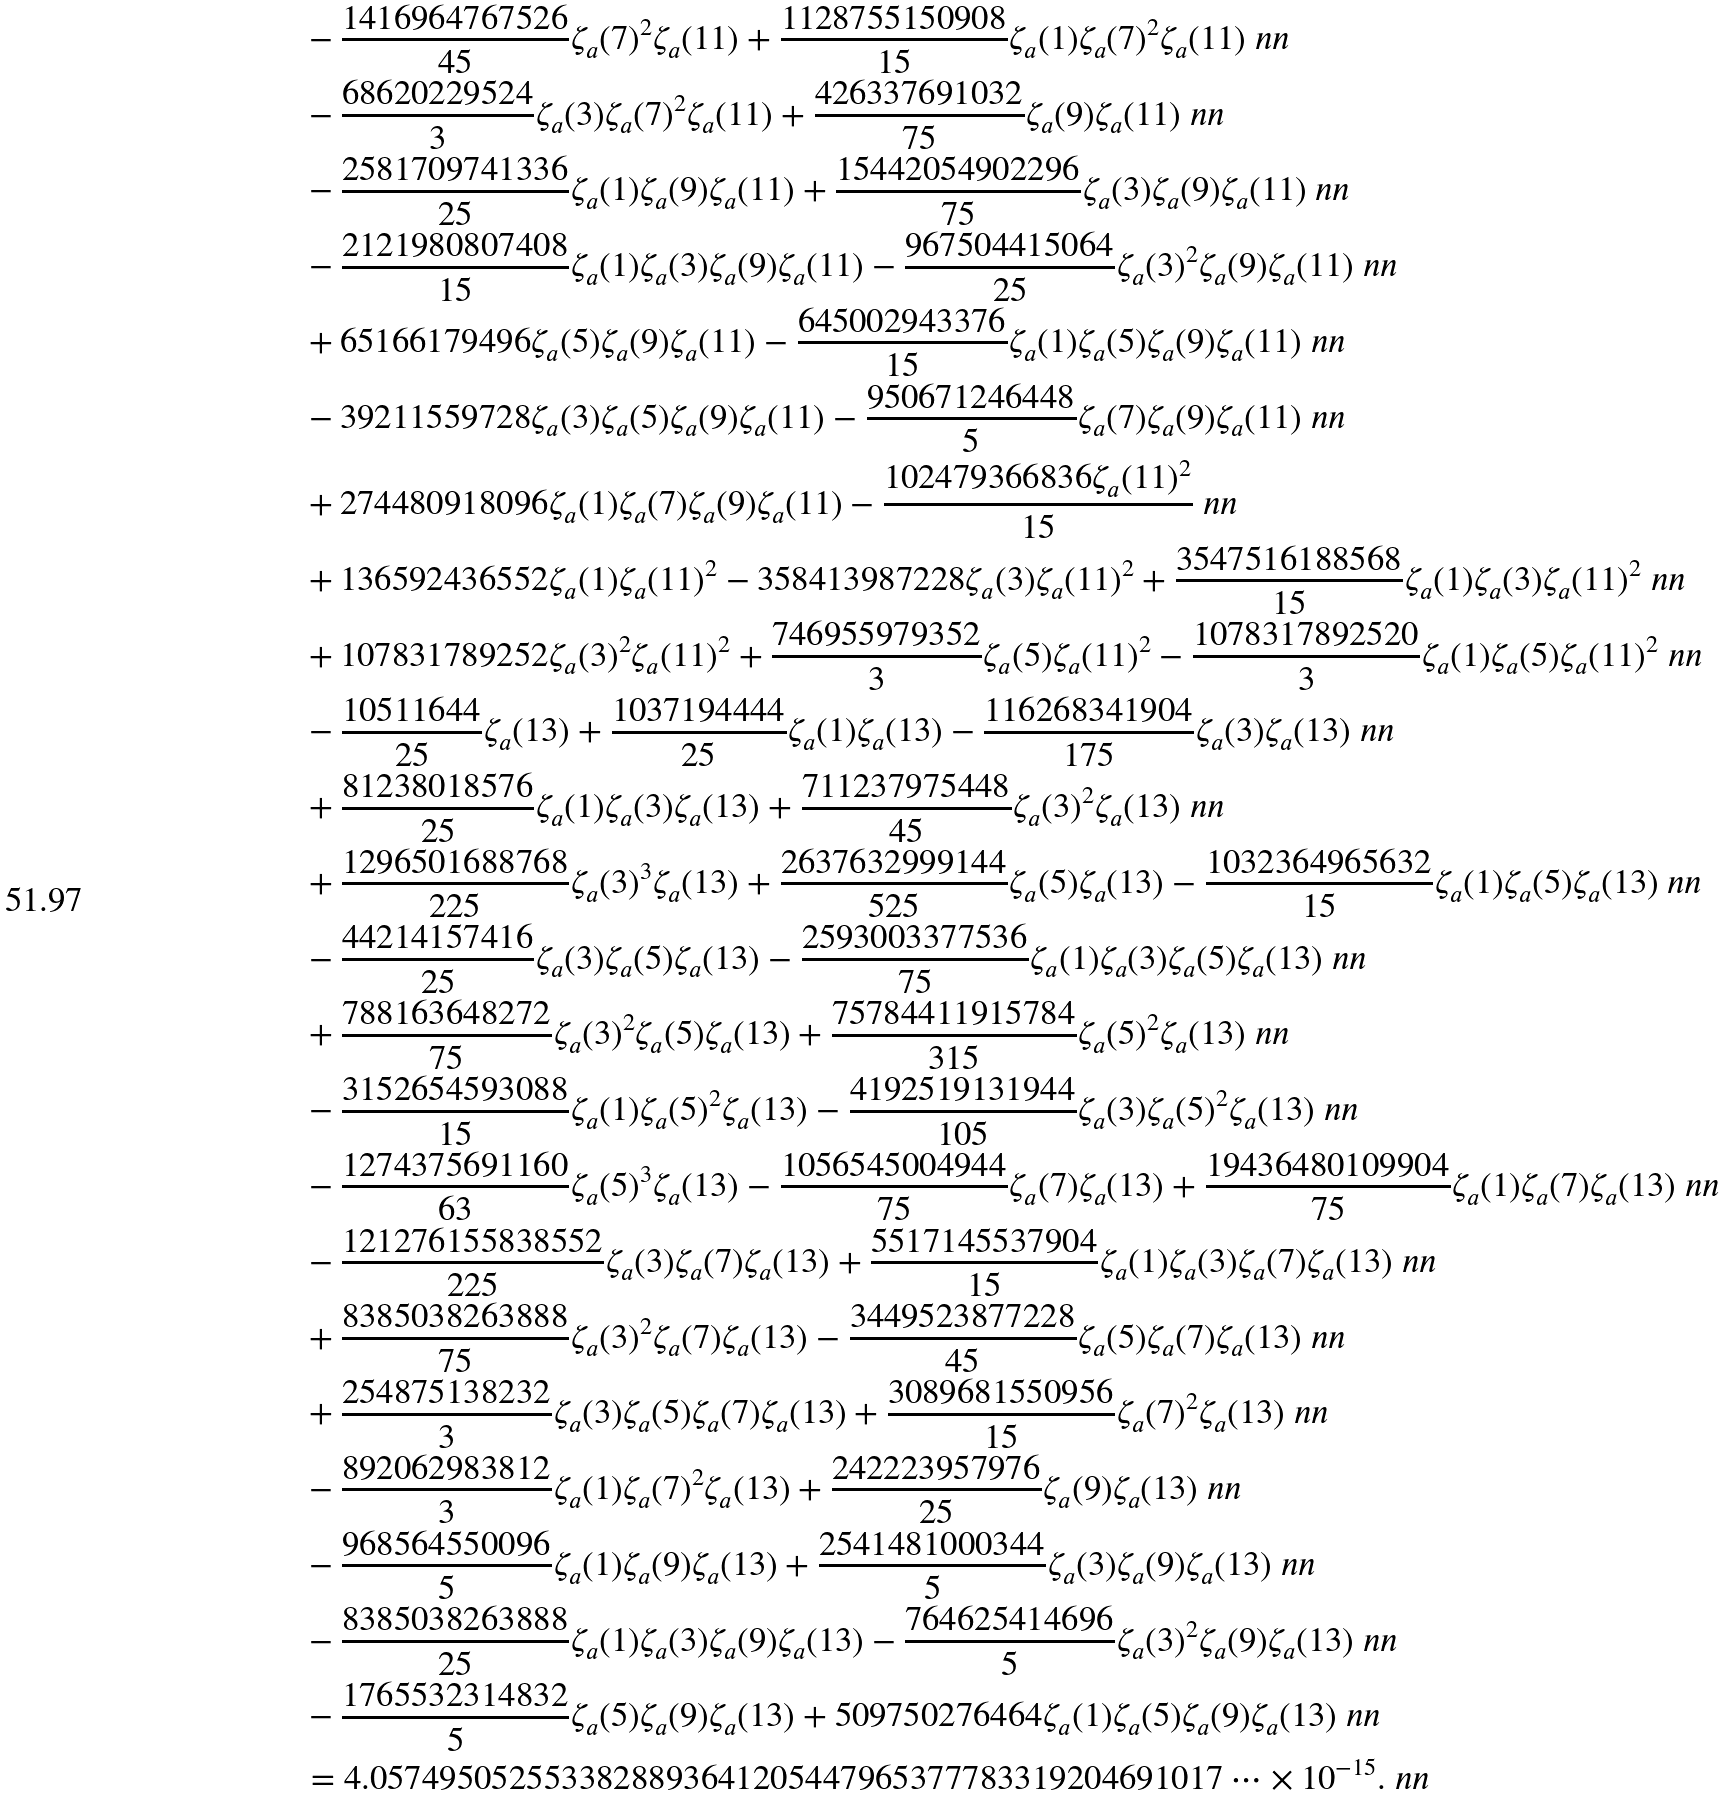<formula> <loc_0><loc_0><loc_500><loc_500>& - \frac { 1 4 1 6 9 6 4 7 6 7 5 2 6 } { 4 5 } \zeta _ { a } ( 7 ) ^ { 2 } \zeta _ { a } ( 1 1 ) + \frac { 1 1 2 8 7 5 5 1 5 0 9 0 8 } { 1 5 } \zeta _ { a } ( 1 ) \zeta _ { a } ( 7 ) ^ { 2 } \zeta _ { a } ( 1 1 ) \ n n \\ & - \frac { 6 8 6 2 0 2 2 9 5 2 4 } { 3 } \zeta _ { a } ( 3 ) \zeta _ { a } ( 7 ) ^ { 2 } \zeta _ { a } ( 1 1 ) + \frac { 4 2 6 3 3 7 6 9 1 0 3 2 } { 7 5 } \zeta _ { a } ( 9 ) \zeta _ { a } ( 1 1 ) \ n n \\ & - \frac { 2 5 8 1 7 0 9 7 4 1 3 3 6 } { 2 5 } \zeta _ { a } ( 1 ) \zeta _ { a } ( 9 ) \zeta _ { a } ( 1 1 ) + \frac { 1 5 4 4 2 0 5 4 9 0 2 2 9 6 } { 7 5 } \zeta _ { a } ( 3 ) \zeta _ { a } ( 9 ) \zeta _ { a } ( 1 1 ) \ n n \\ & - \frac { 2 1 2 1 9 8 0 8 0 7 4 0 8 } { 1 5 } \zeta _ { a } ( 1 ) \zeta _ { a } ( 3 ) \zeta _ { a } ( 9 ) \zeta _ { a } ( 1 1 ) - \frac { 9 6 7 5 0 4 4 1 5 0 6 4 } { 2 5 } \zeta _ { a } ( 3 ) ^ { 2 } \zeta _ { a } ( 9 ) \zeta _ { a } ( 1 1 ) \ n n \\ & + 6 5 1 6 6 1 7 9 4 9 6 \zeta _ { a } ( 5 ) \zeta _ { a } ( 9 ) \zeta _ { a } ( 1 1 ) - \frac { 6 4 5 0 0 2 9 4 3 3 7 6 } { 1 5 } \zeta _ { a } ( 1 ) \zeta _ { a } ( 5 ) \zeta _ { a } ( 9 ) \zeta _ { a } ( 1 1 ) \ n n \\ & - 3 9 2 1 1 5 5 9 7 2 8 \zeta _ { a } ( 3 ) \zeta _ { a } ( 5 ) \zeta _ { a } ( 9 ) \zeta _ { a } ( 1 1 ) - \frac { 9 5 0 6 7 1 2 4 6 4 4 8 } { 5 } \zeta _ { a } ( 7 ) \zeta _ { a } ( 9 ) \zeta _ { a } ( 1 1 ) \ n n \\ & + 2 7 4 4 8 0 9 1 8 0 9 6 \zeta _ { a } ( 1 ) \zeta _ { a } ( 7 ) \zeta _ { a } ( 9 ) \zeta _ { a } ( 1 1 ) - \frac { 1 0 2 4 7 9 3 6 6 8 3 6 \zeta _ { a } ( 1 1 ) ^ { 2 } } { 1 5 } \ n n \\ & + 1 3 6 5 9 2 4 3 6 5 5 2 \zeta _ { a } ( 1 ) \zeta _ { a } ( 1 1 ) ^ { 2 } - 3 5 8 4 1 3 9 8 7 2 2 8 \zeta _ { a } ( 3 ) \zeta _ { a } ( 1 1 ) ^ { 2 } + \frac { 3 5 4 7 5 1 6 1 8 8 5 6 8 } { 1 5 } \zeta _ { a } ( 1 ) \zeta _ { a } ( 3 ) \zeta _ { a } ( 1 1 ) ^ { 2 } \ n n \\ & + 1 0 7 8 3 1 7 8 9 2 5 2 \zeta _ { a } ( 3 ) ^ { 2 } \zeta _ { a } ( 1 1 ) ^ { 2 } + \frac { 7 4 6 9 5 5 9 7 9 3 5 2 } { 3 } \zeta _ { a } ( 5 ) \zeta _ { a } ( 1 1 ) ^ { 2 } - \frac { 1 0 7 8 3 1 7 8 9 2 5 2 0 } { 3 } \zeta _ { a } ( 1 ) \zeta _ { a } ( 5 ) \zeta _ { a } ( 1 1 ) ^ { 2 } \ n n \\ & - \frac { 1 0 5 1 1 6 4 4 } { 2 5 } \zeta _ { a } ( 1 3 ) + \frac { 1 0 3 7 1 9 4 4 4 4 } { 2 5 } \zeta _ { a } ( 1 ) \zeta _ { a } ( 1 3 ) - \frac { 1 1 6 2 6 8 3 4 1 9 0 4 } { 1 7 5 } \zeta _ { a } ( 3 ) \zeta _ { a } ( 1 3 ) \ n n \\ & + \frac { 8 1 2 3 8 0 1 8 5 7 6 } { 2 5 } \zeta _ { a } ( 1 ) \zeta _ { a } ( 3 ) \zeta _ { a } ( 1 3 ) + \frac { 7 1 1 2 3 7 9 7 5 4 4 8 } { 4 5 } \zeta _ { a } ( 3 ) ^ { 2 } \zeta _ { a } ( 1 3 ) \ n n \\ & + \frac { 1 2 9 6 5 0 1 6 8 8 7 6 8 } { 2 2 5 } \zeta _ { a } ( 3 ) ^ { 3 } \zeta _ { a } ( 1 3 ) + \frac { 2 6 3 7 6 3 2 9 9 9 1 4 4 } { 5 2 5 } \zeta _ { a } ( 5 ) \zeta _ { a } ( 1 3 ) - \frac { 1 0 3 2 3 6 4 9 6 5 6 3 2 } { 1 5 } \zeta _ { a } ( 1 ) \zeta _ { a } ( 5 ) \zeta _ { a } ( 1 3 ) \ n n \\ & - \frac { 4 4 2 1 4 1 5 7 4 1 6 } { 2 5 } \zeta _ { a } ( 3 ) \zeta _ { a } ( 5 ) \zeta _ { a } ( 1 3 ) - \frac { 2 5 9 3 0 0 3 3 7 7 5 3 6 } { 7 5 } \zeta _ { a } ( 1 ) \zeta _ { a } ( 3 ) \zeta _ { a } ( 5 ) \zeta _ { a } ( 1 3 ) \ n n \\ & + \frac { 7 8 8 1 6 3 6 4 8 2 7 2 } { 7 5 } \zeta _ { a } ( 3 ) ^ { 2 } \zeta _ { a } ( 5 ) \zeta _ { a } ( 1 3 ) + \frac { 7 5 7 8 4 4 1 1 9 1 5 7 8 4 } { 3 1 5 } \zeta _ { a } ( 5 ) ^ { 2 } \zeta _ { a } ( 1 3 ) \ n n \\ & - \frac { 3 1 5 2 6 5 4 5 9 3 0 8 8 } { 1 5 } \zeta _ { a } ( 1 ) \zeta _ { a } ( 5 ) ^ { 2 } \zeta _ { a } ( 1 3 ) - \frac { 4 1 9 2 5 1 9 1 3 1 9 4 4 } { 1 0 5 } \zeta _ { a } ( 3 ) \zeta _ { a } ( 5 ) ^ { 2 } \zeta _ { a } ( 1 3 ) \ n n \\ & - \frac { 1 2 7 4 3 7 5 6 9 1 1 6 0 } { 6 3 } \zeta _ { a } ( 5 ) ^ { 3 } \zeta _ { a } ( 1 3 ) - \frac { 1 0 5 6 5 4 5 0 0 4 9 4 4 } { 7 5 } \zeta _ { a } ( 7 ) \zeta _ { a } ( 1 3 ) + \frac { 1 9 4 3 6 4 8 0 1 0 9 9 0 4 } { 7 5 } \zeta _ { a } ( 1 ) \zeta _ { a } ( 7 ) \zeta _ { a } ( 1 3 ) \ n n \\ & - \frac { 1 2 1 2 7 6 1 5 5 8 3 8 5 5 2 } { 2 2 5 } \zeta _ { a } ( 3 ) \zeta _ { a } ( 7 ) \zeta _ { a } ( 1 3 ) + \frac { 5 5 1 7 1 4 5 5 3 7 9 0 4 } { 1 5 } \zeta _ { a } ( 1 ) \zeta _ { a } ( 3 ) \zeta _ { a } ( 7 ) \zeta _ { a } ( 1 3 ) \ n n \\ & + \frac { 8 3 8 5 0 3 8 2 6 3 8 8 8 } { 7 5 } \zeta _ { a } ( 3 ) ^ { 2 } \zeta _ { a } ( 7 ) \zeta _ { a } ( 1 3 ) - \frac { 3 4 4 9 5 2 3 8 7 7 2 2 8 } { 4 5 } \zeta _ { a } ( 5 ) \zeta _ { a } ( 7 ) \zeta _ { a } ( 1 3 ) \ n n \\ & + \frac { 2 5 4 8 7 5 1 3 8 2 3 2 } { 3 } \zeta _ { a } ( 3 ) \zeta _ { a } ( 5 ) \zeta _ { a } ( 7 ) \zeta _ { a } ( 1 3 ) + \frac { 3 0 8 9 6 8 1 5 5 0 9 5 6 } { 1 5 } \zeta _ { a } ( 7 ) ^ { 2 } \zeta _ { a } ( 1 3 ) \ n n \\ & - \frac { 8 9 2 0 6 2 9 8 3 8 1 2 } { 3 } \zeta _ { a } ( 1 ) \zeta _ { a } ( 7 ) ^ { 2 } \zeta _ { a } ( 1 3 ) + \frac { 2 4 2 2 2 3 9 5 7 9 7 6 } { 2 5 } \zeta _ { a } ( 9 ) \zeta _ { a } ( 1 3 ) \ n n \\ & - \frac { 9 6 8 5 6 4 5 5 0 0 9 6 } { 5 } \zeta _ { a } ( 1 ) \zeta _ { a } ( 9 ) \zeta _ { a } ( 1 3 ) + \frac { 2 5 4 1 4 8 1 0 0 0 3 4 4 } { 5 } \zeta _ { a } ( 3 ) \zeta _ { a } ( 9 ) \zeta _ { a } ( 1 3 ) \ n n \\ & - \frac { 8 3 8 5 0 3 8 2 6 3 8 8 8 } { 2 5 } \zeta _ { a } ( 1 ) \zeta _ { a } ( 3 ) \zeta _ { a } ( 9 ) \zeta _ { a } ( 1 3 ) - \frac { 7 6 4 6 2 5 4 1 4 6 9 6 } { 5 } \zeta _ { a } ( 3 ) ^ { 2 } \zeta _ { a } ( 9 ) \zeta _ { a } ( 1 3 ) \ n n \\ & - \frac { 1 7 6 5 5 3 2 3 1 4 8 3 2 } { 5 } \zeta _ { a } ( 5 ) \zeta _ { a } ( 9 ) \zeta _ { a } ( 1 3 ) + 5 0 9 7 5 0 2 7 6 4 6 4 \zeta _ { a } ( 1 ) \zeta _ { a } ( 5 ) \zeta _ { a } ( 9 ) \zeta _ { a } ( 1 3 ) \ n n \\ & = 4 . 0 5 7 4 9 5 0 5 2 5 5 3 3 8 2 8 8 9 3 6 4 1 2 0 5 4 4 7 9 6 5 3 7 7 7 8 3 3 1 9 2 0 4 6 9 1 0 1 7 \cdots \times 1 0 ^ { - 1 5 } . \ n n</formula> 